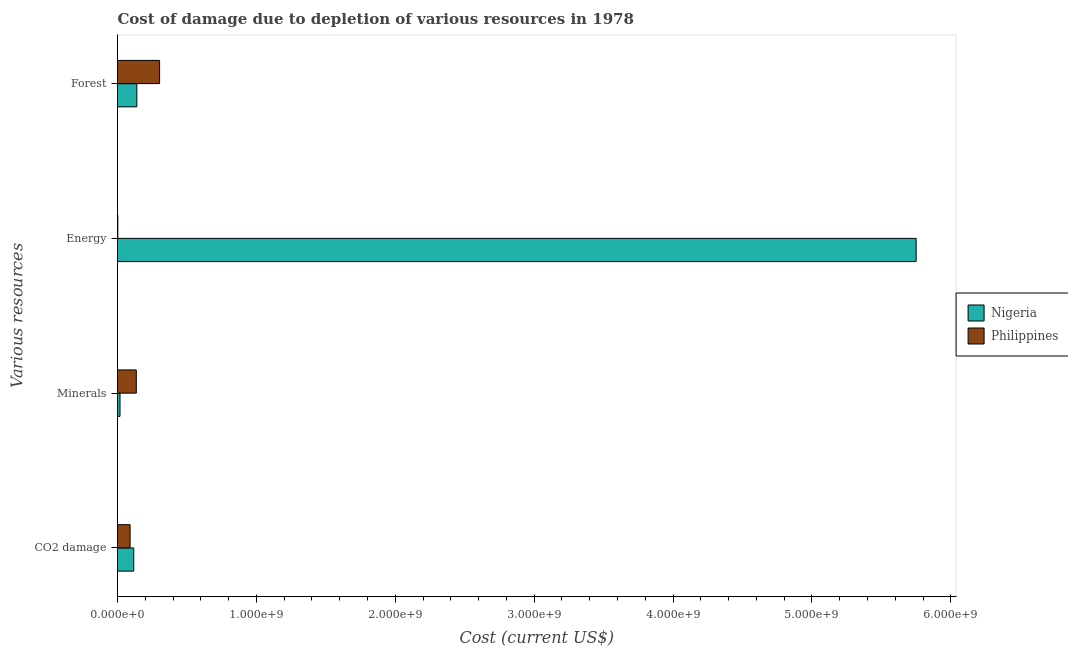How many different coloured bars are there?
Give a very brief answer. 2. How many bars are there on the 2nd tick from the bottom?
Provide a short and direct response. 2. What is the label of the 2nd group of bars from the top?
Offer a terse response. Energy. What is the cost of damage due to depletion of coal in Nigeria?
Offer a very short reply. 1.17e+08. Across all countries, what is the maximum cost of damage due to depletion of energy?
Offer a terse response. 5.75e+09. Across all countries, what is the minimum cost of damage due to depletion of forests?
Your response must be concise. 1.39e+08. In which country was the cost of damage due to depletion of coal maximum?
Offer a very short reply. Nigeria. In which country was the cost of damage due to depletion of forests minimum?
Provide a succinct answer. Nigeria. What is the total cost of damage due to depletion of coal in the graph?
Give a very brief answer. 2.07e+08. What is the difference between the cost of damage due to depletion of coal in Nigeria and that in Philippines?
Provide a succinct answer. 2.62e+07. What is the difference between the cost of damage due to depletion of coal in Nigeria and the cost of damage due to depletion of forests in Philippines?
Make the answer very short. -1.86e+08. What is the average cost of damage due to depletion of minerals per country?
Provide a short and direct response. 7.67e+07. What is the difference between the cost of damage due to depletion of coal and cost of damage due to depletion of energy in Nigeria?
Provide a short and direct response. -5.63e+09. In how many countries, is the cost of damage due to depletion of coal greater than 2800000000 US$?
Provide a succinct answer. 0. What is the ratio of the cost of damage due to depletion of coal in Nigeria to that in Philippines?
Offer a very short reply. 1.29. Is the difference between the cost of damage due to depletion of forests in Nigeria and Philippines greater than the difference between the cost of damage due to depletion of energy in Nigeria and Philippines?
Your answer should be very brief. No. What is the difference between the highest and the second highest cost of damage due to depletion of minerals?
Your answer should be compact. 1.17e+08. What is the difference between the highest and the lowest cost of damage due to depletion of energy?
Offer a terse response. 5.75e+09. Is it the case that in every country, the sum of the cost of damage due to depletion of energy and cost of damage due to depletion of minerals is greater than the sum of cost of damage due to depletion of forests and cost of damage due to depletion of coal?
Ensure brevity in your answer.  No. What does the 2nd bar from the top in Minerals represents?
Provide a short and direct response. Nigeria. What does the 2nd bar from the bottom in Energy represents?
Keep it short and to the point. Philippines. Are all the bars in the graph horizontal?
Your response must be concise. Yes. Are the values on the major ticks of X-axis written in scientific E-notation?
Your response must be concise. Yes. Does the graph contain any zero values?
Provide a short and direct response. No. Does the graph contain grids?
Your answer should be very brief. No. How many legend labels are there?
Give a very brief answer. 2. How are the legend labels stacked?
Offer a very short reply. Vertical. What is the title of the graph?
Make the answer very short. Cost of damage due to depletion of various resources in 1978 . Does "Ethiopia" appear as one of the legend labels in the graph?
Ensure brevity in your answer.  No. What is the label or title of the X-axis?
Your response must be concise. Cost (current US$). What is the label or title of the Y-axis?
Ensure brevity in your answer.  Various resources. What is the Cost (current US$) of Nigeria in CO2 damage?
Keep it short and to the point. 1.17e+08. What is the Cost (current US$) of Philippines in CO2 damage?
Your answer should be compact. 9.06e+07. What is the Cost (current US$) in Nigeria in Minerals?
Offer a terse response. 1.80e+07. What is the Cost (current US$) in Philippines in Minerals?
Provide a succinct answer. 1.35e+08. What is the Cost (current US$) in Nigeria in Energy?
Provide a succinct answer. 5.75e+09. What is the Cost (current US$) of Philippines in Energy?
Provide a short and direct response. 2.02e+06. What is the Cost (current US$) in Nigeria in Forest?
Keep it short and to the point. 1.39e+08. What is the Cost (current US$) in Philippines in Forest?
Make the answer very short. 3.03e+08. Across all Various resources, what is the maximum Cost (current US$) of Nigeria?
Give a very brief answer. 5.75e+09. Across all Various resources, what is the maximum Cost (current US$) in Philippines?
Give a very brief answer. 3.03e+08. Across all Various resources, what is the minimum Cost (current US$) of Nigeria?
Keep it short and to the point. 1.80e+07. Across all Various resources, what is the minimum Cost (current US$) in Philippines?
Give a very brief answer. 2.02e+06. What is the total Cost (current US$) in Nigeria in the graph?
Keep it short and to the point. 6.02e+09. What is the total Cost (current US$) of Philippines in the graph?
Your answer should be very brief. 5.31e+08. What is the difference between the Cost (current US$) of Nigeria in CO2 damage and that in Minerals?
Offer a very short reply. 9.88e+07. What is the difference between the Cost (current US$) of Philippines in CO2 damage and that in Minerals?
Your answer should be very brief. -4.46e+07. What is the difference between the Cost (current US$) of Nigeria in CO2 damage and that in Energy?
Make the answer very short. -5.63e+09. What is the difference between the Cost (current US$) of Philippines in CO2 damage and that in Energy?
Your answer should be compact. 8.86e+07. What is the difference between the Cost (current US$) of Nigeria in CO2 damage and that in Forest?
Offer a very short reply. -2.22e+07. What is the difference between the Cost (current US$) in Philippines in CO2 damage and that in Forest?
Your response must be concise. -2.12e+08. What is the difference between the Cost (current US$) in Nigeria in Minerals and that in Energy?
Offer a very short reply. -5.73e+09. What is the difference between the Cost (current US$) of Philippines in Minerals and that in Energy?
Provide a succinct answer. 1.33e+08. What is the difference between the Cost (current US$) of Nigeria in Minerals and that in Forest?
Provide a short and direct response. -1.21e+08. What is the difference between the Cost (current US$) of Philippines in Minerals and that in Forest?
Your answer should be compact. -1.68e+08. What is the difference between the Cost (current US$) in Nigeria in Energy and that in Forest?
Your response must be concise. 5.61e+09. What is the difference between the Cost (current US$) of Philippines in Energy and that in Forest?
Your answer should be very brief. -3.01e+08. What is the difference between the Cost (current US$) of Nigeria in CO2 damage and the Cost (current US$) of Philippines in Minerals?
Provide a succinct answer. -1.85e+07. What is the difference between the Cost (current US$) in Nigeria in CO2 damage and the Cost (current US$) in Philippines in Energy?
Provide a succinct answer. 1.15e+08. What is the difference between the Cost (current US$) of Nigeria in CO2 damage and the Cost (current US$) of Philippines in Forest?
Your answer should be very brief. -1.86e+08. What is the difference between the Cost (current US$) in Nigeria in Minerals and the Cost (current US$) in Philippines in Energy?
Provide a succinct answer. 1.60e+07. What is the difference between the Cost (current US$) of Nigeria in Minerals and the Cost (current US$) of Philippines in Forest?
Give a very brief answer. -2.85e+08. What is the difference between the Cost (current US$) in Nigeria in Energy and the Cost (current US$) in Philippines in Forest?
Give a very brief answer. 5.45e+09. What is the average Cost (current US$) of Nigeria per Various resources?
Provide a short and direct response. 1.51e+09. What is the average Cost (current US$) of Philippines per Various resources?
Your answer should be compact. 1.33e+08. What is the difference between the Cost (current US$) of Nigeria and Cost (current US$) of Philippines in CO2 damage?
Offer a very short reply. 2.62e+07. What is the difference between the Cost (current US$) of Nigeria and Cost (current US$) of Philippines in Minerals?
Give a very brief answer. -1.17e+08. What is the difference between the Cost (current US$) in Nigeria and Cost (current US$) in Philippines in Energy?
Give a very brief answer. 5.75e+09. What is the difference between the Cost (current US$) of Nigeria and Cost (current US$) of Philippines in Forest?
Ensure brevity in your answer.  -1.64e+08. What is the ratio of the Cost (current US$) of Nigeria in CO2 damage to that in Minerals?
Offer a very short reply. 6.48. What is the ratio of the Cost (current US$) in Philippines in CO2 damage to that in Minerals?
Your answer should be compact. 0.67. What is the ratio of the Cost (current US$) of Nigeria in CO2 damage to that in Energy?
Offer a very short reply. 0.02. What is the ratio of the Cost (current US$) in Philippines in CO2 damage to that in Energy?
Keep it short and to the point. 44.93. What is the ratio of the Cost (current US$) of Nigeria in CO2 damage to that in Forest?
Make the answer very short. 0.84. What is the ratio of the Cost (current US$) in Philippines in CO2 damage to that in Forest?
Your answer should be compact. 0.3. What is the ratio of the Cost (current US$) of Nigeria in Minerals to that in Energy?
Make the answer very short. 0. What is the ratio of the Cost (current US$) in Philippines in Minerals to that in Energy?
Keep it short and to the point. 67.06. What is the ratio of the Cost (current US$) in Nigeria in Minerals to that in Forest?
Keep it short and to the point. 0.13. What is the ratio of the Cost (current US$) of Philippines in Minerals to that in Forest?
Keep it short and to the point. 0.45. What is the ratio of the Cost (current US$) of Nigeria in Energy to that in Forest?
Keep it short and to the point. 41.38. What is the ratio of the Cost (current US$) of Philippines in Energy to that in Forest?
Your answer should be very brief. 0.01. What is the difference between the highest and the second highest Cost (current US$) of Nigeria?
Your answer should be compact. 5.61e+09. What is the difference between the highest and the second highest Cost (current US$) in Philippines?
Offer a terse response. 1.68e+08. What is the difference between the highest and the lowest Cost (current US$) of Nigeria?
Your answer should be compact. 5.73e+09. What is the difference between the highest and the lowest Cost (current US$) of Philippines?
Give a very brief answer. 3.01e+08. 